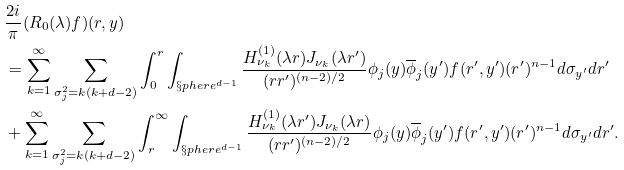Convert formula to latex. <formula><loc_0><loc_0><loc_500><loc_500>& \frac { 2 i } { \pi } ( R _ { 0 } ( \lambda ) f ) ( r , y ) \\ & = \sum _ { k = 1 } ^ { \infty } \sum _ { \sigma _ { j } ^ { 2 } = k ( k + d - 2 ) } \int _ { 0 } ^ { r } \int _ { \S p h e r e ^ { d - 1 } } \frac { H ^ { ( 1 ) } _ { \nu _ { k } } ( \lambda r ) J _ { \nu _ { k } } ( \lambda r ^ { \prime } ) } { ( r r ^ { \prime } ) ^ { ( n - 2 ) / 2 } } \phi _ { j } ( y ) \overline { \phi } _ { j } ( y ^ { \prime } ) f ( r ^ { \prime } , y ^ { \prime } ) ( r ^ { \prime } ) ^ { n - 1 } d \sigma _ { y ^ { \prime } } d r ^ { \prime } \\ & + \sum _ { k = 1 } ^ { \infty } \sum _ { \sigma _ { j } ^ { 2 } = k ( k + d - 2 ) } \int _ { r } ^ { \infty } \int _ { \S p h e r e ^ { d - 1 } } \frac { H ^ { ( 1 ) } _ { \nu _ { k } } ( \lambda r ^ { \prime } ) J _ { \nu _ { k } } ( \lambda r ) } { ( r r ^ { \prime } ) ^ { ( n - 2 ) / 2 } } \phi _ { j } ( y ) \overline { \phi } _ { j } ( y ^ { \prime } ) f ( r ^ { \prime } , y ^ { \prime } ) ( r ^ { \prime } ) ^ { n - 1 } d \sigma _ { y ^ { \prime } } d r ^ { \prime } .</formula> 